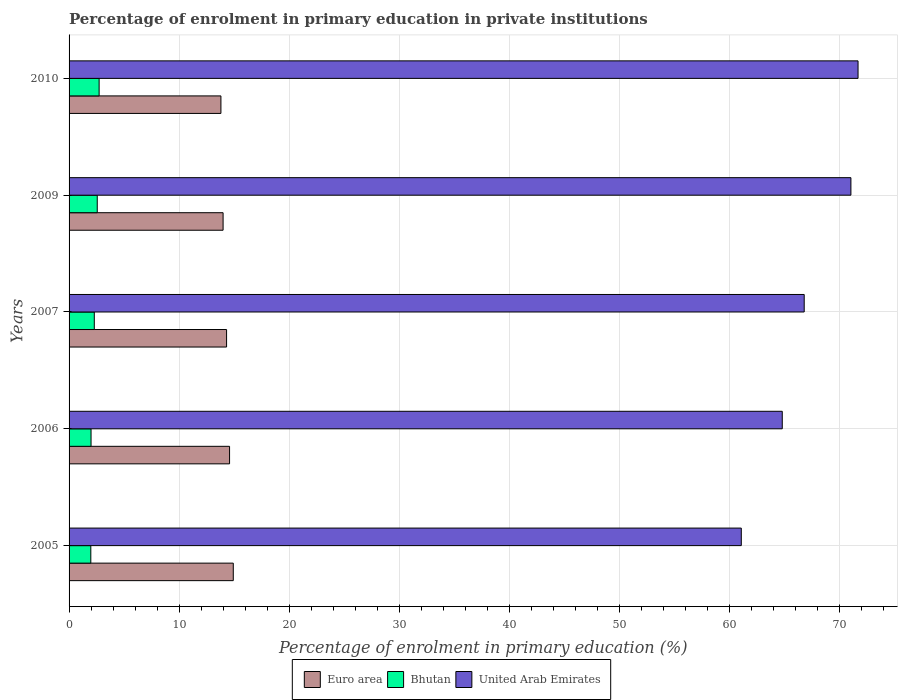Are the number of bars per tick equal to the number of legend labels?
Give a very brief answer. Yes. Are the number of bars on each tick of the Y-axis equal?
Offer a terse response. Yes. How many bars are there on the 4th tick from the top?
Make the answer very short. 3. How many bars are there on the 3rd tick from the bottom?
Keep it short and to the point. 3. In how many cases, is the number of bars for a given year not equal to the number of legend labels?
Your response must be concise. 0. What is the percentage of enrolment in primary education in Bhutan in 2007?
Your response must be concise. 2.29. Across all years, what is the maximum percentage of enrolment in primary education in Bhutan?
Your answer should be very brief. 2.73. Across all years, what is the minimum percentage of enrolment in primary education in Bhutan?
Offer a terse response. 1.97. In which year was the percentage of enrolment in primary education in Bhutan minimum?
Give a very brief answer. 2005. What is the total percentage of enrolment in primary education in United Arab Emirates in the graph?
Give a very brief answer. 335.34. What is the difference between the percentage of enrolment in primary education in Bhutan in 2005 and that in 2009?
Provide a short and direct response. -0.58. What is the difference between the percentage of enrolment in primary education in United Arab Emirates in 2006 and the percentage of enrolment in primary education in Bhutan in 2005?
Make the answer very short. 62.82. What is the average percentage of enrolment in primary education in Euro area per year?
Offer a terse response. 14.32. In the year 2009, what is the difference between the percentage of enrolment in primary education in United Arab Emirates and percentage of enrolment in primary education in Bhutan?
Keep it short and to the point. 68.47. What is the ratio of the percentage of enrolment in primary education in United Arab Emirates in 2006 to that in 2007?
Your answer should be very brief. 0.97. Is the percentage of enrolment in primary education in Bhutan in 2005 less than that in 2007?
Keep it short and to the point. Yes. Is the difference between the percentage of enrolment in primary education in United Arab Emirates in 2005 and 2010 greater than the difference between the percentage of enrolment in primary education in Bhutan in 2005 and 2010?
Make the answer very short. No. What is the difference between the highest and the second highest percentage of enrolment in primary education in United Arab Emirates?
Provide a succinct answer. 0.65. What is the difference between the highest and the lowest percentage of enrolment in primary education in Euro area?
Keep it short and to the point. 1.12. In how many years, is the percentage of enrolment in primary education in Euro area greater than the average percentage of enrolment in primary education in Euro area taken over all years?
Your response must be concise. 2. Is the sum of the percentage of enrolment in primary education in Euro area in 2006 and 2010 greater than the maximum percentage of enrolment in primary education in Bhutan across all years?
Your answer should be very brief. Yes. What does the 2nd bar from the top in 2006 represents?
Your answer should be compact. Bhutan. How many bars are there?
Provide a short and direct response. 15. How many years are there in the graph?
Your answer should be compact. 5. What is the difference between two consecutive major ticks on the X-axis?
Your answer should be very brief. 10. Does the graph contain any zero values?
Ensure brevity in your answer.  No. Where does the legend appear in the graph?
Make the answer very short. Bottom center. How are the legend labels stacked?
Provide a succinct answer. Horizontal. What is the title of the graph?
Offer a terse response. Percentage of enrolment in primary education in private institutions. What is the label or title of the X-axis?
Keep it short and to the point. Percentage of enrolment in primary education (%). What is the Percentage of enrolment in primary education (%) in Euro area in 2005?
Your answer should be very brief. 14.92. What is the Percentage of enrolment in primary education (%) of Bhutan in 2005?
Keep it short and to the point. 1.97. What is the Percentage of enrolment in primary education (%) in United Arab Emirates in 2005?
Ensure brevity in your answer.  61.07. What is the Percentage of enrolment in primary education (%) of Euro area in 2006?
Your answer should be compact. 14.58. What is the Percentage of enrolment in primary education (%) in Bhutan in 2006?
Ensure brevity in your answer.  2. What is the Percentage of enrolment in primary education (%) in United Arab Emirates in 2006?
Offer a very short reply. 64.79. What is the Percentage of enrolment in primary education (%) in Euro area in 2007?
Provide a succinct answer. 14.31. What is the Percentage of enrolment in primary education (%) of Bhutan in 2007?
Your answer should be compact. 2.29. What is the Percentage of enrolment in primary education (%) in United Arab Emirates in 2007?
Give a very brief answer. 66.78. What is the Percentage of enrolment in primary education (%) of Euro area in 2009?
Offer a very short reply. 13.99. What is the Percentage of enrolment in primary education (%) of Bhutan in 2009?
Give a very brief answer. 2.56. What is the Percentage of enrolment in primary education (%) in United Arab Emirates in 2009?
Make the answer very short. 71.03. What is the Percentage of enrolment in primary education (%) of Euro area in 2010?
Your answer should be compact. 13.8. What is the Percentage of enrolment in primary education (%) in Bhutan in 2010?
Offer a terse response. 2.73. What is the Percentage of enrolment in primary education (%) in United Arab Emirates in 2010?
Make the answer very short. 71.67. Across all years, what is the maximum Percentage of enrolment in primary education (%) of Euro area?
Ensure brevity in your answer.  14.92. Across all years, what is the maximum Percentage of enrolment in primary education (%) in Bhutan?
Make the answer very short. 2.73. Across all years, what is the maximum Percentage of enrolment in primary education (%) in United Arab Emirates?
Your response must be concise. 71.67. Across all years, what is the minimum Percentage of enrolment in primary education (%) in Euro area?
Provide a succinct answer. 13.8. Across all years, what is the minimum Percentage of enrolment in primary education (%) in Bhutan?
Offer a very short reply. 1.97. Across all years, what is the minimum Percentage of enrolment in primary education (%) of United Arab Emirates?
Keep it short and to the point. 61.07. What is the total Percentage of enrolment in primary education (%) in Euro area in the graph?
Make the answer very short. 71.59. What is the total Percentage of enrolment in primary education (%) in Bhutan in the graph?
Provide a succinct answer. 11.55. What is the total Percentage of enrolment in primary education (%) in United Arab Emirates in the graph?
Provide a succinct answer. 335.34. What is the difference between the Percentage of enrolment in primary education (%) in Euro area in 2005 and that in 2006?
Offer a terse response. 0.34. What is the difference between the Percentage of enrolment in primary education (%) in Bhutan in 2005 and that in 2006?
Offer a very short reply. -0.02. What is the difference between the Percentage of enrolment in primary education (%) of United Arab Emirates in 2005 and that in 2006?
Ensure brevity in your answer.  -3.72. What is the difference between the Percentage of enrolment in primary education (%) of Euro area in 2005 and that in 2007?
Your answer should be compact. 0.61. What is the difference between the Percentage of enrolment in primary education (%) of Bhutan in 2005 and that in 2007?
Make the answer very short. -0.32. What is the difference between the Percentage of enrolment in primary education (%) of United Arab Emirates in 2005 and that in 2007?
Keep it short and to the point. -5.72. What is the difference between the Percentage of enrolment in primary education (%) in Euro area in 2005 and that in 2009?
Your answer should be compact. 0.93. What is the difference between the Percentage of enrolment in primary education (%) of Bhutan in 2005 and that in 2009?
Your answer should be very brief. -0.58. What is the difference between the Percentage of enrolment in primary education (%) in United Arab Emirates in 2005 and that in 2009?
Your answer should be very brief. -9.96. What is the difference between the Percentage of enrolment in primary education (%) in Euro area in 2005 and that in 2010?
Your answer should be very brief. 1.12. What is the difference between the Percentage of enrolment in primary education (%) of Bhutan in 2005 and that in 2010?
Your answer should be very brief. -0.76. What is the difference between the Percentage of enrolment in primary education (%) of United Arab Emirates in 2005 and that in 2010?
Keep it short and to the point. -10.61. What is the difference between the Percentage of enrolment in primary education (%) in Euro area in 2006 and that in 2007?
Your answer should be compact. 0.27. What is the difference between the Percentage of enrolment in primary education (%) of Bhutan in 2006 and that in 2007?
Offer a terse response. -0.3. What is the difference between the Percentage of enrolment in primary education (%) of United Arab Emirates in 2006 and that in 2007?
Provide a succinct answer. -1.99. What is the difference between the Percentage of enrolment in primary education (%) in Euro area in 2006 and that in 2009?
Offer a very short reply. 0.59. What is the difference between the Percentage of enrolment in primary education (%) of Bhutan in 2006 and that in 2009?
Keep it short and to the point. -0.56. What is the difference between the Percentage of enrolment in primary education (%) of United Arab Emirates in 2006 and that in 2009?
Offer a very short reply. -6.24. What is the difference between the Percentage of enrolment in primary education (%) in Euro area in 2006 and that in 2010?
Provide a short and direct response. 0.78. What is the difference between the Percentage of enrolment in primary education (%) in Bhutan in 2006 and that in 2010?
Keep it short and to the point. -0.73. What is the difference between the Percentage of enrolment in primary education (%) of United Arab Emirates in 2006 and that in 2010?
Provide a succinct answer. -6.88. What is the difference between the Percentage of enrolment in primary education (%) of Euro area in 2007 and that in 2009?
Your answer should be compact. 0.32. What is the difference between the Percentage of enrolment in primary education (%) of Bhutan in 2007 and that in 2009?
Provide a short and direct response. -0.27. What is the difference between the Percentage of enrolment in primary education (%) of United Arab Emirates in 2007 and that in 2009?
Offer a very short reply. -4.24. What is the difference between the Percentage of enrolment in primary education (%) in Euro area in 2007 and that in 2010?
Your response must be concise. 0.51. What is the difference between the Percentage of enrolment in primary education (%) in Bhutan in 2007 and that in 2010?
Provide a short and direct response. -0.44. What is the difference between the Percentage of enrolment in primary education (%) of United Arab Emirates in 2007 and that in 2010?
Your response must be concise. -4.89. What is the difference between the Percentage of enrolment in primary education (%) in Euro area in 2009 and that in 2010?
Offer a terse response. 0.2. What is the difference between the Percentage of enrolment in primary education (%) of Bhutan in 2009 and that in 2010?
Offer a very short reply. -0.17. What is the difference between the Percentage of enrolment in primary education (%) of United Arab Emirates in 2009 and that in 2010?
Your answer should be compact. -0.65. What is the difference between the Percentage of enrolment in primary education (%) of Euro area in 2005 and the Percentage of enrolment in primary education (%) of Bhutan in 2006?
Your answer should be very brief. 12.92. What is the difference between the Percentage of enrolment in primary education (%) of Euro area in 2005 and the Percentage of enrolment in primary education (%) of United Arab Emirates in 2006?
Ensure brevity in your answer.  -49.87. What is the difference between the Percentage of enrolment in primary education (%) of Bhutan in 2005 and the Percentage of enrolment in primary education (%) of United Arab Emirates in 2006?
Your answer should be very brief. -62.82. What is the difference between the Percentage of enrolment in primary education (%) in Euro area in 2005 and the Percentage of enrolment in primary education (%) in Bhutan in 2007?
Keep it short and to the point. 12.63. What is the difference between the Percentage of enrolment in primary education (%) in Euro area in 2005 and the Percentage of enrolment in primary education (%) in United Arab Emirates in 2007?
Your answer should be compact. -51.87. What is the difference between the Percentage of enrolment in primary education (%) in Bhutan in 2005 and the Percentage of enrolment in primary education (%) in United Arab Emirates in 2007?
Your answer should be compact. -64.81. What is the difference between the Percentage of enrolment in primary education (%) in Euro area in 2005 and the Percentage of enrolment in primary education (%) in Bhutan in 2009?
Your response must be concise. 12.36. What is the difference between the Percentage of enrolment in primary education (%) in Euro area in 2005 and the Percentage of enrolment in primary education (%) in United Arab Emirates in 2009?
Your answer should be very brief. -56.11. What is the difference between the Percentage of enrolment in primary education (%) in Bhutan in 2005 and the Percentage of enrolment in primary education (%) in United Arab Emirates in 2009?
Give a very brief answer. -69.05. What is the difference between the Percentage of enrolment in primary education (%) of Euro area in 2005 and the Percentage of enrolment in primary education (%) of Bhutan in 2010?
Provide a short and direct response. 12.19. What is the difference between the Percentage of enrolment in primary education (%) of Euro area in 2005 and the Percentage of enrolment in primary education (%) of United Arab Emirates in 2010?
Ensure brevity in your answer.  -56.76. What is the difference between the Percentage of enrolment in primary education (%) in Bhutan in 2005 and the Percentage of enrolment in primary education (%) in United Arab Emirates in 2010?
Provide a short and direct response. -69.7. What is the difference between the Percentage of enrolment in primary education (%) of Euro area in 2006 and the Percentage of enrolment in primary education (%) of Bhutan in 2007?
Offer a terse response. 12.29. What is the difference between the Percentage of enrolment in primary education (%) of Euro area in 2006 and the Percentage of enrolment in primary education (%) of United Arab Emirates in 2007?
Your answer should be compact. -52.2. What is the difference between the Percentage of enrolment in primary education (%) in Bhutan in 2006 and the Percentage of enrolment in primary education (%) in United Arab Emirates in 2007?
Your answer should be compact. -64.79. What is the difference between the Percentage of enrolment in primary education (%) in Euro area in 2006 and the Percentage of enrolment in primary education (%) in Bhutan in 2009?
Your answer should be very brief. 12.02. What is the difference between the Percentage of enrolment in primary education (%) in Euro area in 2006 and the Percentage of enrolment in primary education (%) in United Arab Emirates in 2009?
Provide a succinct answer. -56.45. What is the difference between the Percentage of enrolment in primary education (%) in Bhutan in 2006 and the Percentage of enrolment in primary education (%) in United Arab Emirates in 2009?
Your answer should be compact. -69.03. What is the difference between the Percentage of enrolment in primary education (%) of Euro area in 2006 and the Percentage of enrolment in primary education (%) of Bhutan in 2010?
Give a very brief answer. 11.85. What is the difference between the Percentage of enrolment in primary education (%) of Euro area in 2006 and the Percentage of enrolment in primary education (%) of United Arab Emirates in 2010?
Provide a short and direct response. -57.09. What is the difference between the Percentage of enrolment in primary education (%) of Bhutan in 2006 and the Percentage of enrolment in primary education (%) of United Arab Emirates in 2010?
Offer a terse response. -69.68. What is the difference between the Percentage of enrolment in primary education (%) of Euro area in 2007 and the Percentage of enrolment in primary education (%) of Bhutan in 2009?
Your answer should be compact. 11.75. What is the difference between the Percentage of enrolment in primary education (%) of Euro area in 2007 and the Percentage of enrolment in primary education (%) of United Arab Emirates in 2009?
Your answer should be very brief. -56.72. What is the difference between the Percentage of enrolment in primary education (%) in Bhutan in 2007 and the Percentage of enrolment in primary education (%) in United Arab Emirates in 2009?
Your answer should be compact. -68.73. What is the difference between the Percentage of enrolment in primary education (%) of Euro area in 2007 and the Percentage of enrolment in primary education (%) of Bhutan in 2010?
Your response must be concise. 11.58. What is the difference between the Percentage of enrolment in primary education (%) in Euro area in 2007 and the Percentage of enrolment in primary education (%) in United Arab Emirates in 2010?
Make the answer very short. -57.37. What is the difference between the Percentage of enrolment in primary education (%) of Bhutan in 2007 and the Percentage of enrolment in primary education (%) of United Arab Emirates in 2010?
Make the answer very short. -69.38. What is the difference between the Percentage of enrolment in primary education (%) of Euro area in 2009 and the Percentage of enrolment in primary education (%) of Bhutan in 2010?
Keep it short and to the point. 11.26. What is the difference between the Percentage of enrolment in primary education (%) of Euro area in 2009 and the Percentage of enrolment in primary education (%) of United Arab Emirates in 2010?
Your response must be concise. -57.68. What is the difference between the Percentage of enrolment in primary education (%) of Bhutan in 2009 and the Percentage of enrolment in primary education (%) of United Arab Emirates in 2010?
Ensure brevity in your answer.  -69.11. What is the average Percentage of enrolment in primary education (%) in Euro area per year?
Provide a short and direct response. 14.32. What is the average Percentage of enrolment in primary education (%) in Bhutan per year?
Make the answer very short. 2.31. What is the average Percentage of enrolment in primary education (%) in United Arab Emirates per year?
Your answer should be very brief. 67.07. In the year 2005, what is the difference between the Percentage of enrolment in primary education (%) in Euro area and Percentage of enrolment in primary education (%) in Bhutan?
Give a very brief answer. 12.94. In the year 2005, what is the difference between the Percentage of enrolment in primary education (%) in Euro area and Percentage of enrolment in primary education (%) in United Arab Emirates?
Make the answer very short. -46.15. In the year 2005, what is the difference between the Percentage of enrolment in primary education (%) of Bhutan and Percentage of enrolment in primary education (%) of United Arab Emirates?
Ensure brevity in your answer.  -59.09. In the year 2006, what is the difference between the Percentage of enrolment in primary education (%) in Euro area and Percentage of enrolment in primary education (%) in Bhutan?
Your answer should be compact. 12.58. In the year 2006, what is the difference between the Percentage of enrolment in primary education (%) in Euro area and Percentage of enrolment in primary education (%) in United Arab Emirates?
Your answer should be very brief. -50.21. In the year 2006, what is the difference between the Percentage of enrolment in primary education (%) in Bhutan and Percentage of enrolment in primary education (%) in United Arab Emirates?
Give a very brief answer. -62.79. In the year 2007, what is the difference between the Percentage of enrolment in primary education (%) in Euro area and Percentage of enrolment in primary education (%) in Bhutan?
Your answer should be very brief. 12.02. In the year 2007, what is the difference between the Percentage of enrolment in primary education (%) in Euro area and Percentage of enrolment in primary education (%) in United Arab Emirates?
Your answer should be very brief. -52.48. In the year 2007, what is the difference between the Percentage of enrolment in primary education (%) in Bhutan and Percentage of enrolment in primary education (%) in United Arab Emirates?
Provide a short and direct response. -64.49. In the year 2009, what is the difference between the Percentage of enrolment in primary education (%) in Euro area and Percentage of enrolment in primary education (%) in Bhutan?
Your answer should be very brief. 11.43. In the year 2009, what is the difference between the Percentage of enrolment in primary education (%) in Euro area and Percentage of enrolment in primary education (%) in United Arab Emirates?
Provide a short and direct response. -57.03. In the year 2009, what is the difference between the Percentage of enrolment in primary education (%) in Bhutan and Percentage of enrolment in primary education (%) in United Arab Emirates?
Keep it short and to the point. -68.47. In the year 2010, what is the difference between the Percentage of enrolment in primary education (%) of Euro area and Percentage of enrolment in primary education (%) of Bhutan?
Give a very brief answer. 11.07. In the year 2010, what is the difference between the Percentage of enrolment in primary education (%) of Euro area and Percentage of enrolment in primary education (%) of United Arab Emirates?
Provide a succinct answer. -57.88. In the year 2010, what is the difference between the Percentage of enrolment in primary education (%) of Bhutan and Percentage of enrolment in primary education (%) of United Arab Emirates?
Your answer should be very brief. -68.94. What is the ratio of the Percentage of enrolment in primary education (%) of Euro area in 2005 to that in 2006?
Keep it short and to the point. 1.02. What is the ratio of the Percentage of enrolment in primary education (%) of United Arab Emirates in 2005 to that in 2006?
Keep it short and to the point. 0.94. What is the ratio of the Percentage of enrolment in primary education (%) of Euro area in 2005 to that in 2007?
Keep it short and to the point. 1.04. What is the ratio of the Percentage of enrolment in primary education (%) of Bhutan in 2005 to that in 2007?
Your answer should be compact. 0.86. What is the ratio of the Percentage of enrolment in primary education (%) in United Arab Emirates in 2005 to that in 2007?
Provide a succinct answer. 0.91. What is the ratio of the Percentage of enrolment in primary education (%) in Euro area in 2005 to that in 2009?
Offer a very short reply. 1.07. What is the ratio of the Percentage of enrolment in primary education (%) of Bhutan in 2005 to that in 2009?
Your response must be concise. 0.77. What is the ratio of the Percentage of enrolment in primary education (%) of United Arab Emirates in 2005 to that in 2009?
Your answer should be very brief. 0.86. What is the ratio of the Percentage of enrolment in primary education (%) in Euro area in 2005 to that in 2010?
Offer a very short reply. 1.08. What is the ratio of the Percentage of enrolment in primary education (%) in Bhutan in 2005 to that in 2010?
Provide a short and direct response. 0.72. What is the ratio of the Percentage of enrolment in primary education (%) in United Arab Emirates in 2005 to that in 2010?
Your answer should be compact. 0.85. What is the ratio of the Percentage of enrolment in primary education (%) of Euro area in 2006 to that in 2007?
Offer a terse response. 1.02. What is the ratio of the Percentage of enrolment in primary education (%) in Bhutan in 2006 to that in 2007?
Keep it short and to the point. 0.87. What is the ratio of the Percentage of enrolment in primary education (%) of United Arab Emirates in 2006 to that in 2007?
Make the answer very short. 0.97. What is the ratio of the Percentage of enrolment in primary education (%) in Euro area in 2006 to that in 2009?
Keep it short and to the point. 1.04. What is the ratio of the Percentage of enrolment in primary education (%) of Bhutan in 2006 to that in 2009?
Your response must be concise. 0.78. What is the ratio of the Percentage of enrolment in primary education (%) of United Arab Emirates in 2006 to that in 2009?
Provide a short and direct response. 0.91. What is the ratio of the Percentage of enrolment in primary education (%) in Euro area in 2006 to that in 2010?
Offer a terse response. 1.06. What is the ratio of the Percentage of enrolment in primary education (%) in Bhutan in 2006 to that in 2010?
Make the answer very short. 0.73. What is the ratio of the Percentage of enrolment in primary education (%) in United Arab Emirates in 2006 to that in 2010?
Your answer should be very brief. 0.9. What is the ratio of the Percentage of enrolment in primary education (%) of Euro area in 2007 to that in 2009?
Keep it short and to the point. 1.02. What is the ratio of the Percentage of enrolment in primary education (%) of Bhutan in 2007 to that in 2009?
Make the answer very short. 0.9. What is the ratio of the Percentage of enrolment in primary education (%) in United Arab Emirates in 2007 to that in 2009?
Your answer should be very brief. 0.94. What is the ratio of the Percentage of enrolment in primary education (%) in Euro area in 2007 to that in 2010?
Make the answer very short. 1.04. What is the ratio of the Percentage of enrolment in primary education (%) of Bhutan in 2007 to that in 2010?
Your response must be concise. 0.84. What is the ratio of the Percentage of enrolment in primary education (%) of United Arab Emirates in 2007 to that in 2010?
Your response must be concise. 0.93. What is the ratio of the Percentage of enrolment in primary education (%) in Euro area in 2009 to that in 2010?
Provide a short and direct response. 1.01. What is the ratio of the Percentage of enrolment in primary education (%) in Bhutan in 2009 to that in 2010?
Provide a succinct answer. 0.94. What is the ratio of the Percentage of enrolment in primary education (%) in United Arab Emirates in 2009 to that in 2010?
Your answer should be compact. 0.99. What is the difference between the highest and the second highest Percentage of enrolment in primary education (%) in Euro area?
Your response must be concise. 0.34. What is the difference between the highest and the second highest Percentage of enrolment in primary education (%) of Bhutan?
Your answer should be very brief. 0.17. What is the difference between the highest and the second highest Percentage of enrolment in primary education (%) of United Arab Emirates?
Your answer should be compact. 0.65. What is the difference between the highest and the lowest Percentage of enrolment in primary education (%) of Euro area?
Offer a very short reply. 1.12. What is the difference between the highest and the lowest Percentage of enrolment in primary education (%) in Bhutan?
Provide a succinct answer. 0.76. What is the difference between the highest and the lowest Percentage of enrolment in primary education (%) of United Arab Emirates?
Your answer should be compact. 10.61. 